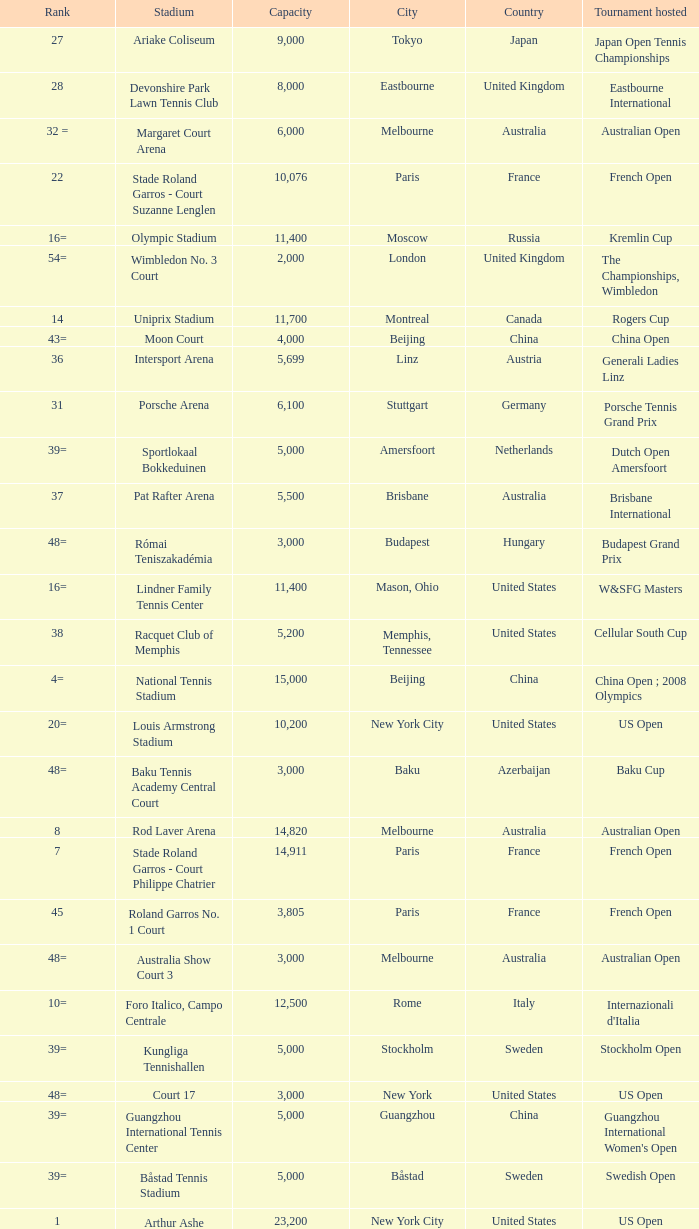What is the average capacity that has rod laver arena as the stadium? 14820.0. 